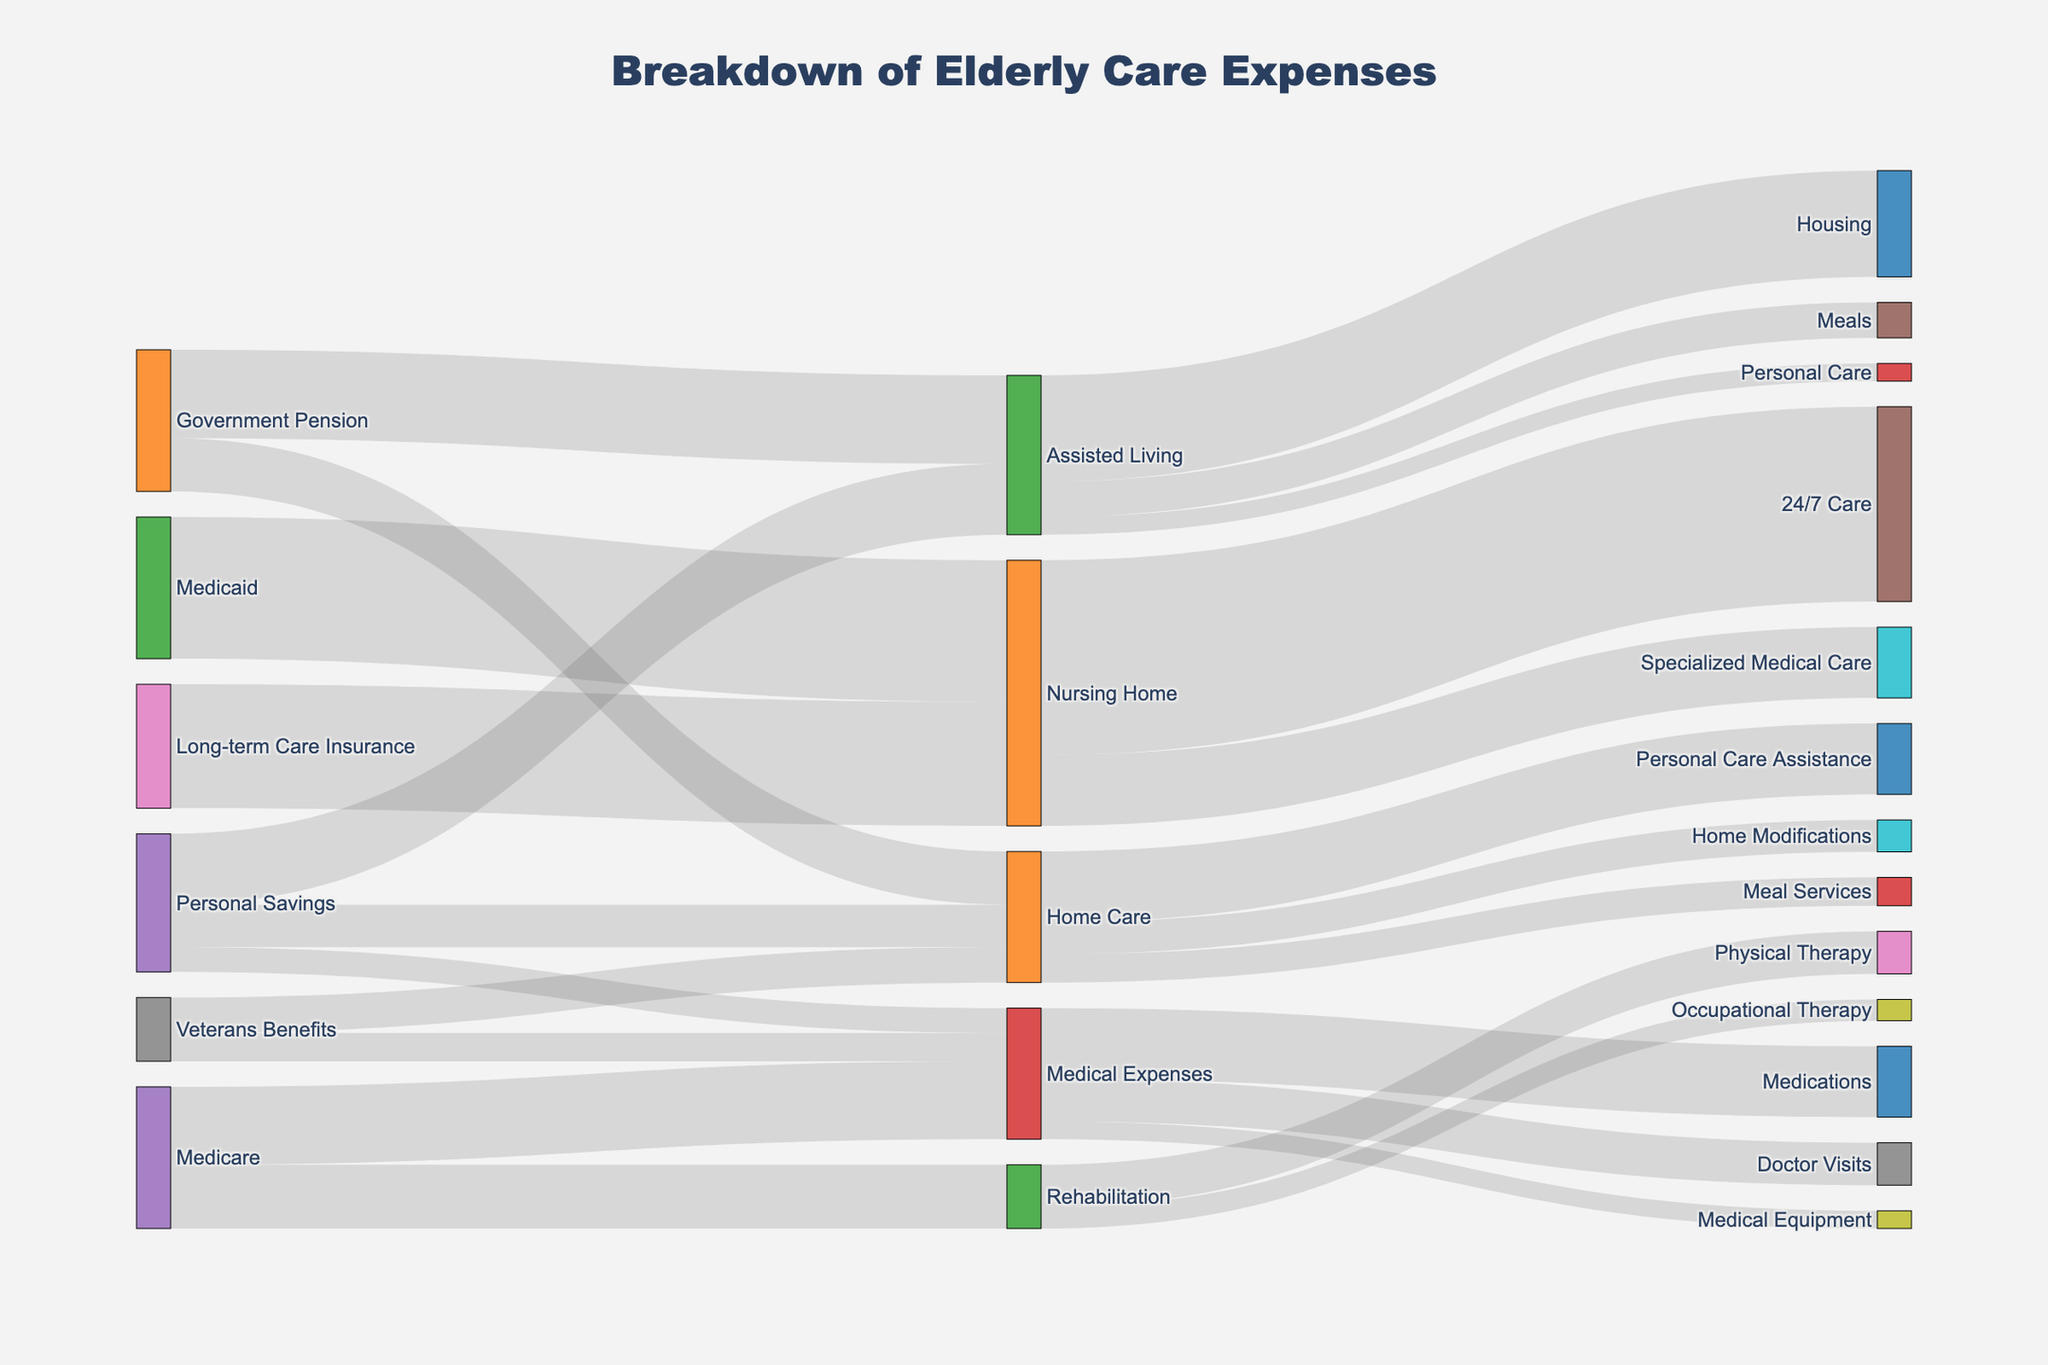How much funding does Home Care receive from Personal Savings? Look for the flow from "Personal Savings" to "Home Care" in the Sankey diagram. The value shown is the amount of funding.
Answer: 12000 Which category gets the most funding from Medicare? Refer to the flows originating from "Medicare" and identify which target has the largest value.
Answer: Medical Expenses How much total funding is directed towards Medical Expenses? Sum all the flows that have "Medical Expenses" as the target: Veterans Benefits to Medical Expenses (8000), Personal Savings to Medical Expenses (7000), and Medicare to Medical Expenses (22000). 8000+7000+22000 = 37000.
Answer: 37000 What is the largest funding source for Nursing Home care? Check the flows heading to "Nursing Home" and identify the source with the greatest value. "Medicaid" to Nursing Home (40000) and Long-term Care Insurance to Nursing Home (35000).
Answer: Medicaid How much funding is provided by Veterans Benefits in total? Sum the flows originating from "Veterans Benefits": Home Care (10000) and Medical Expenses (8000). 10000 + 8000 = 18000.
Answer: 18000 Which care category receives the most funding from Government Pension? Compare the values of all flows from "Government Pension": Home Care (15000) and Assisted Living (25000). The maximum value is for Assisted Living.
Answer: Assisted Living How much funding is allocated towards 24/7 Care in Nursing Homes? Refer to the flow from "Nursing Home" to "24/7 Care" and read the value.
Answer: 55000 How does the funding for Personal Care in Assisted Living compare to Personal Care Assistance in Home Care? Look at the values for "Assisted Living" to "Personal Care" (5000) and compare it to "Home Care" to "Personal Care Assistance" (20000).
Answer: 5000 vs 20000 What percentage of Medicare funding goes towards Rehabilitation? Look for the flows from "Medicare". The total from Medicare is towards Rehabilitation (18000) and Medical Expenses (22000), summing to 40000. The percentage is (18000 / 40000) * 100 = 45%.
Answer: 45% How much do Home Care, Assisted Living, and Nursing Home care receive from Personal Savings in total? Sum the values for all flows from "Personal Savings" towards Home Care (12000), Assisted Living (20000), and Medical Expenses (7000). 12000 + 20000 + 7000 = 39000.
Answer: 39000 